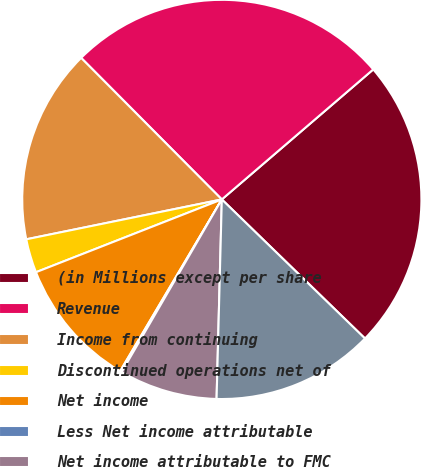Convert chart. <chart><loc_0><loc_0><loc_500><loc_500><pie_chart><fcel>(in Millions except per share<fcel>Revenue<fcel>Income from continuing<fcel>Discontinued operations net of<fcel>Net income<fcel>Less Net income attributable<fcel>Net income attributable to FMC<fcel>Continuing operations net of<nl><fcel>23.56%<fcel>26.16%<fcel>15.75%<fcel>2.74%<fcel>10.55%<fcel>0.14%<fcel>7.95%<fcel>13.15%<nl></chart> 